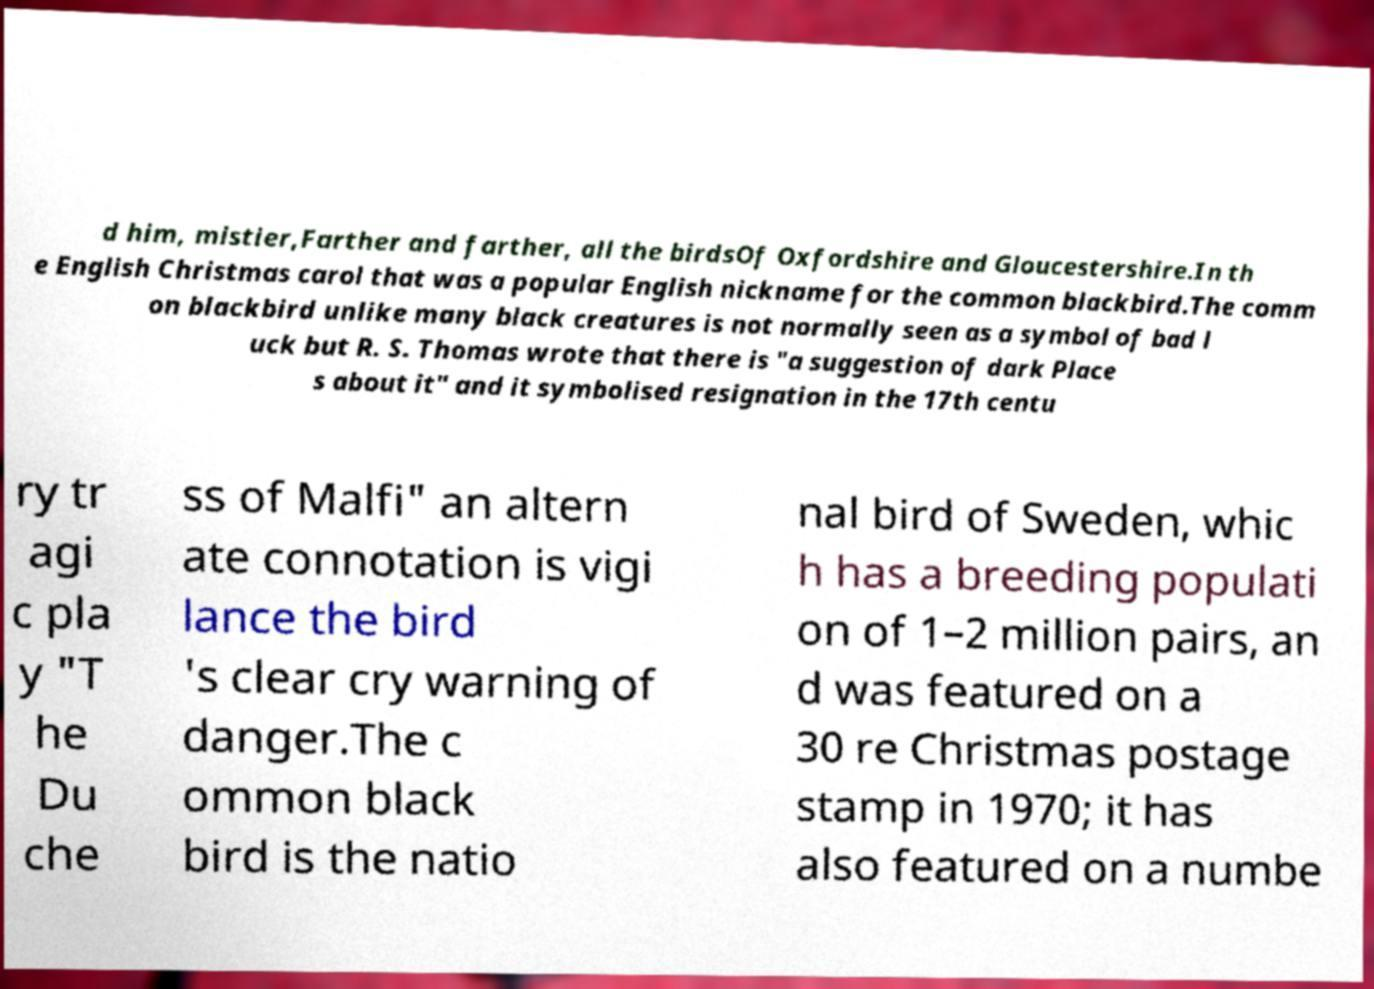Can you read and provide the text displayed in the image?This photo seems to have some interesting text. Can you extract and type it out for me? d him, mistier,Farther and farther, all the birdsOf Oxfordshire and Gloucestershire.In th e English Christmas carol that was a popular English nickname for the common blackbird.The comm on blackbird unlike many black creatures is not normally seen as a symbol of bad l uck but R. S. Thomas wrote that there is "a suggestion of dark Place s about it" and it symbolised resignation in the 17th centu ry tr agi c pla y "T he Du che ss of Malfi" an altern ate connotation is vigi lance the bird 's clear cry warning of danger.The c ommon black bird is the natio nal bird of Sweden, whic h has a breeding populati on of 1–2 million pairs, an d was featured on a 30 re Christmas postage stamp in 1970; it has also featured on a numbe 